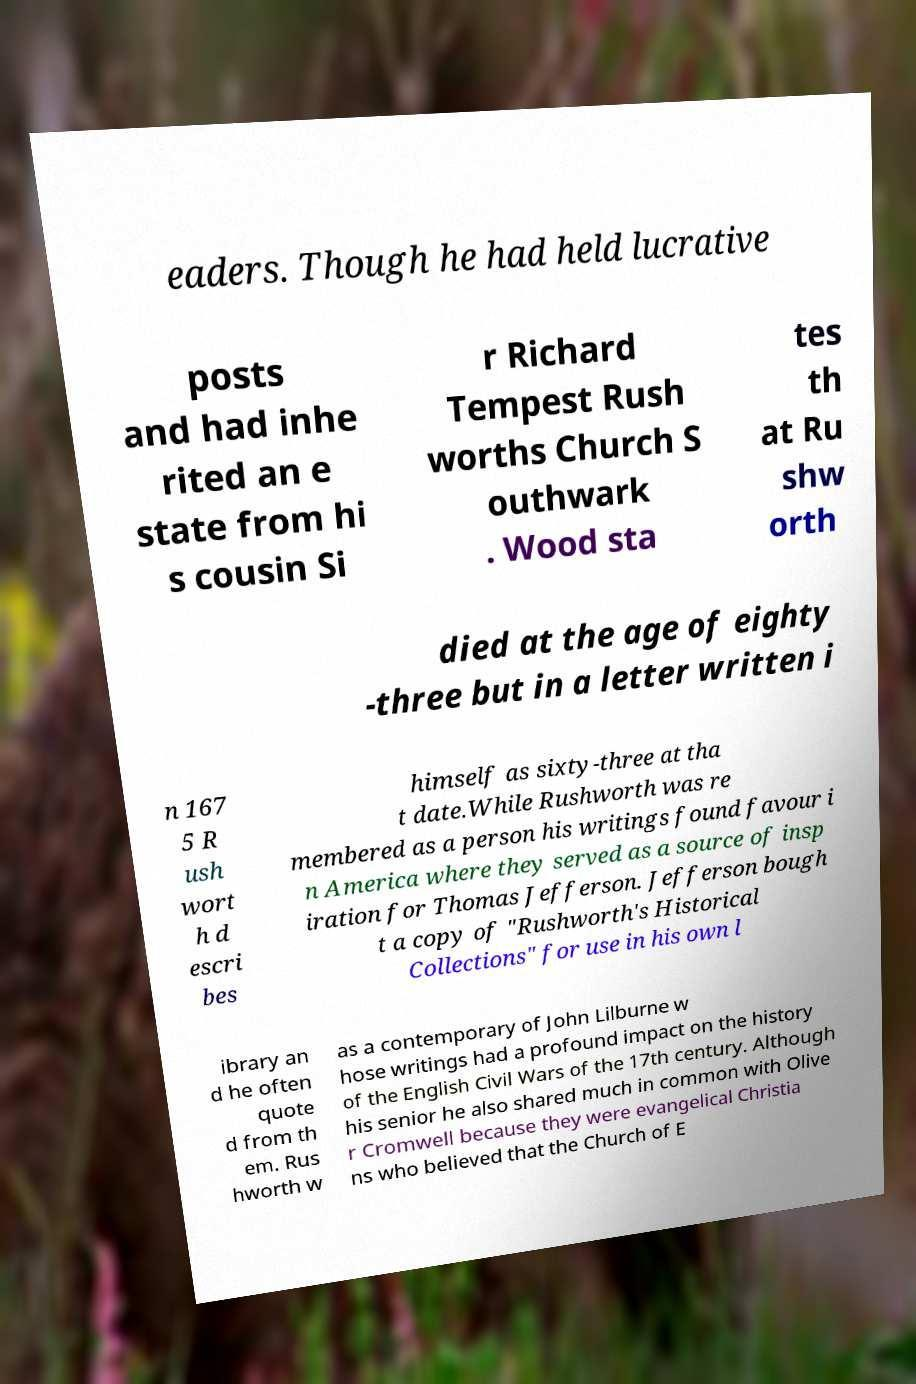There's text embedded in this image that I need extracted. Can you transcribe it verbatim? eaders. Though he had held lucrative posts and had inhe rited an e state from hi s cousin Si r Richard Tempest Rush worths Church S outhwark . Wood sta tes th at Ru shw orth died at the age of eighty -three but in a letter written i n 167 5 R ush wort h d escri bes himself as sixty-three at tha t date.While Rushworth was re membered as a person his writings found favour i n America where they served as a source of insp iration for Thomas Jefferson. Jefferson bough t a copy of "Rushworth's Historical Collections" for use in his own l ibrary an d he often quote d from th em. Rus hworth w as a contemporary of John Lilburne w hose writings had a profound impact on the history of the English Civil Wars of the 17th century. Although his senior he also shared much in common with Olive r Cromwell because they were evangelical Christia ns who believed that the Church of E 